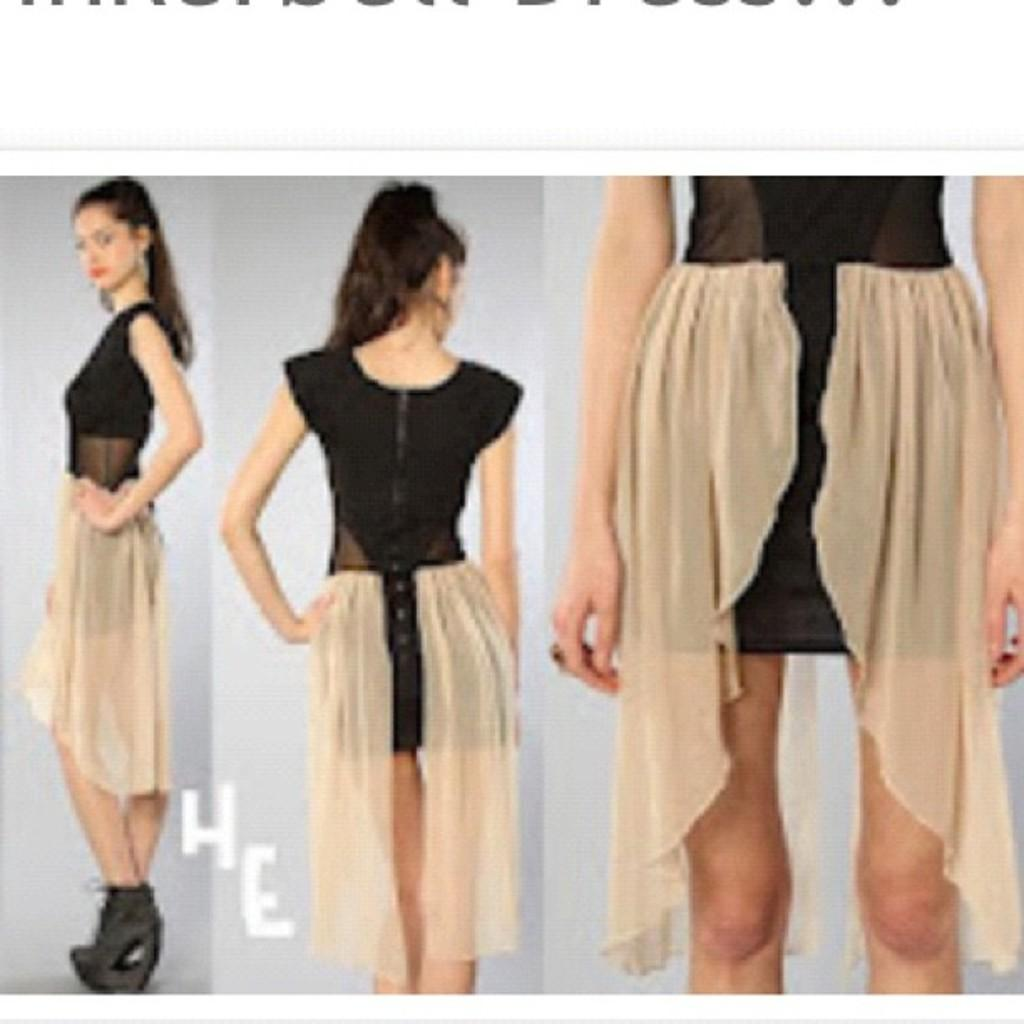How many women are depicted in the picture? There are three images of women in the picture. What are the women wearing in the images? Each woman is wearing a dress. Can you describe the colors of the dresses in the images? One woman's dress is blue, and another's is green. What is the color of the background in the images? The background of the images is grey. What type of toy can be seen in the hands of the woman wearing the blue dress? There is no toy present in the image; the woman wearing the blue dress is not holding anything. 